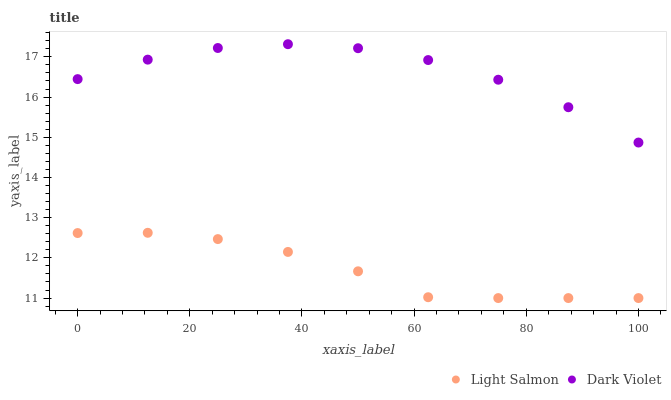Does Light Salmon have the minimum area under the curve?
Answer yes or no. Yes. Does Dark Violet have the maximum area under the curve?
Answer yes or no. Yes. Does Dark Violet have the minimum area under the curve?
Answer yes or no. No. Is Light Salmon the smoothest?
Answer yes or no. Yes. Is Dark Violet the roughest?
Answer yes or no. Yes. Is Dark Violet the smoothest?
Answer yes or no. No. Does Light Salmon have the lowest value?
Answer yes or no. Yes. Does Dark Violet have the lowest value?
Answer yes or no. No. Does Dark Violet have the highest value?
Answer yes or no. Yes. Is Light Salmon less than Dark Violet?
Answer yes or no. Yes. Is Dark Violet greater than Light Salmon?
Answer yes or no. Yes. Does Light Salmon intersect Dark Violet?
Answer yes or no. No. 